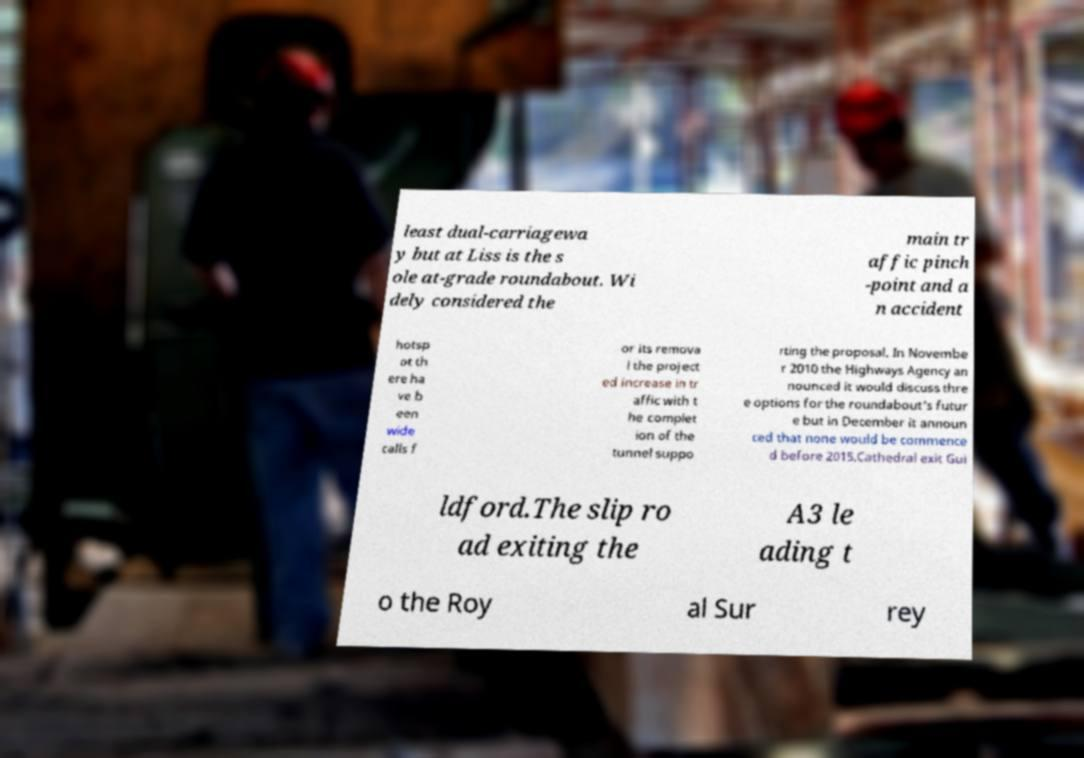Could you extract and type out the text from this image? least dual-carriagewa y but at Liss is the s ole at-grade roundabout. Wi dely considered the main tr affic pinch -point and a n accident hotsp ot th ere ha ve b een wide calls f or its remova l the project ed increase in tr affic with t he complet ion of the tunnel suppo rting the proposal. In Novembe r 2010 the Highways Agency an nounced it would discuss thre e options for the roundabout's futur e but in December it announ ced that none would be commence d before 2015.Cathedral exit Gui ldford.The slip ro ad exiting the A3 le ading t o the Roy al Sur rey 